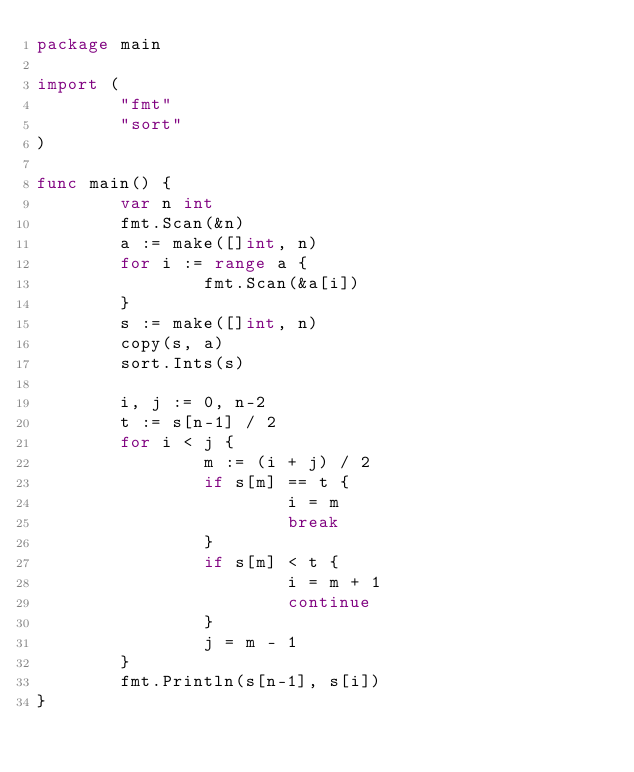<code> <loc_0><loc_0><loc_500><loc_500><_Go_>package main

import (
        "fmt"
        "sort"
)

func main() {
        var n int
        fmt.Scan(&n)
        a := make([]int, n)
        for i := range a {
                fmt.Scan(&a[i])
        }
        s := make([]int, n)
        copy(s, a)
        sort.Ints(s)

        i, j := 0, n-2
        t := s[n-1] / 2
        for i < j {
                m := (i + j) / 2
                if s[m] == t {
                        i = m
                        break
                }
                if s[m] < t {
                        i = m + 1
                        continue
                }
                j = m - 1
        }
        fmt.Println(s[n-1], s[i])
}</code> 